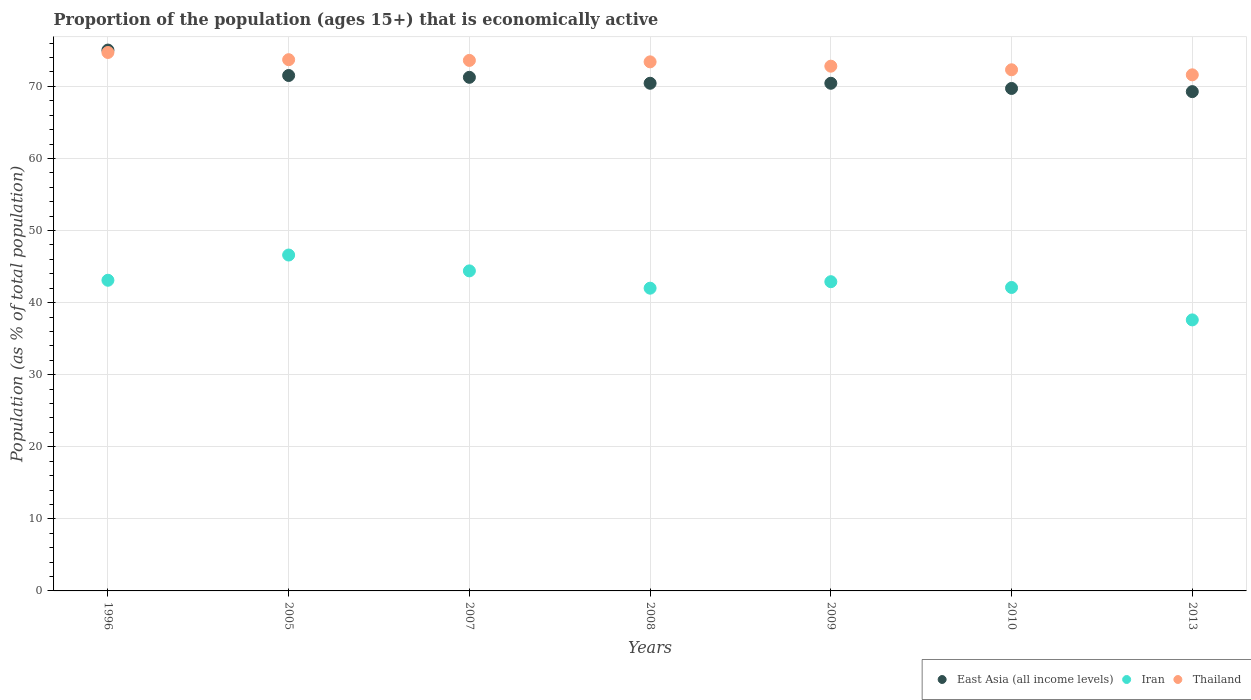How many different coloured dotlines are there?
Provide a succinct answer. 3. What is the proportion of the population that is economically active in Thailand in 2009?
Your answer should be very brief. 72.8. Across all years, what is the maximum proportion of the population that is economically active in East Asia (all income levels)?
Provide a succinct answer. 75.04. Across all years, what is the minimum proportion of the population that is economically active in Iran?
Keep it short and to the point. 37.6. What is the total proportion of the population that is economically active in Iran in the graph?
Offer a very short reply. 298.7. What is the difference between the proportion of the population that is economically active in Thailand in 2008 and that in 2009?
Give a very brief answer. 0.6. What is the difference between the proportion of the population that is economically active in Iran in 2007 and the proportion of the population that is economically active in Thailand in 2010?
Your answer should be very brief. -27.9. What is the average proportion of the population that is economically active in Thailand per year?
Offer a terse response. 73.16. In the year 1996, what is the difference between the proportion of the population that is economically active in Iran and proportion of the population that is economically active in East Asia (all income levels)?
Keep it short and to the point. -31.94. What is the ratio of the proportion of the population that is economically active in East Asia (all income levels) in 1996 to that in 2005?
Your response must be concise. 1.05. Is the proportion of the population that is economically active in East Asia (all income levels) in 2009 less than that in 2013?
Make the answer very short. No. What is the difference between the highest and the second highest proportion of the population that is economically active in East Asia (all income levels)?
Offer a terse response. 3.53. What is the difference between the highest and the lowest proportion of the population that is economically active in Thailand?
Ensure brevity in your answer.  3.1. In how many years, is the proportion of the population that is economically active in Thailand greater than the average proportion of the population that is economically active in Thailand taken over all years?
Provide a short and direct response. 4. Is the sum of the proportion of the population that is economically active in East Asia (all income levels) in 2007 and 2009 greater than the maximum proportion of the population that is economically active in Iran across all years?
Provide a short and direct response. Yes. Is it the case that in every year, the sum of the proportion of the population that is economically active in Iran and proportion of the population that is economically active in Thailand  is greater than the proportion of the population that is economically active in East Asia (all income levels)?
Your response must be concise. Yes. Is the proportion of the population that is economically active in East Asia (all income levels) strictly less than the proportion of the population that is economically active in Iran over the years?
Make the answer very short. No. What is the difference between two consecutive major ticks on the Y-axis?
Make the answer very short. 10. Does the graph contain grids?
Make the answer very short. Yes. How are the legend labels stacked?
Offer a terse response. Horizontal. What is the title of the graph?
Make the answer very short. Proportion of the population (ages 15+) that is economically active. Does "Sweden" appear as one of the legend labels in the graph?
Your answer should be compact. No. What is the label or title of the Y-axis?
Your answer should be compact. Population (as % of total population). What is the Population (as % of total population) in East Asia (all income levels) in 1996?
Your answer should be compact. 75.04. What is the Population (as % of total population) in Iran in 1996?
Provide a short and direct response. 43.1. What is the Population (as % of total population) in Thailand in 1996?
Provide a short and direct response. 74.7. What is the Population (as % of total population) in East Asia (all income levels) in 2005?
Provide a succinct answer. 71.51. What is the Population (as % of total population) in Iran in 2005?
Give a very brief answer. 46.6. What is the Population (as % of total population) in Thailand in 2005?
Your answer should be compact. 73.7. What is the Population (as % of total population) of East Asia (all income levels) in 2007?
Provide a succinct answer. 71.25. What is the Population (as % of total population) in Iran in 2007?
Offer a terse response. 44.4. What is the Population (as % of total population) of Thailand in 2007?
Ensure brevity in your answer.  73.6. What is the Population (as % of total population) of East Asia (all income levels) in 2008?
Your response must be concise. 70.43. What is the Population (as % of total population) of Thailand in 2008?
Your response must be concise. 73.4. What is the Population (as % of total population) of East Asia (all income levels) in 2009?
Keep it short and to the point. 70.43. What is the Population (as % of total population) of Iran in 2009?
Keep it short and to the point. 42.9. What is the Population (as % of total population) of Thailand in 2009?
Your response must be concise. 72.8. What is the Population (as % of total population) in East Asia (all income levels) in 2010?
Your answer should be compact. 69.71. What is the Population (as % of total population) of Iran in 2010?
Give a very brief answer. 42.1. What is the Population (as % of total population) in Thailand in 2010?
Make the answer very short. 72.3. What is the Population (as % of total population) in East Asia (all income levels) in 2013?
Your answer should be compact. 69.27. What is the Population (as % of total population) in Iran in 2013?
Ensure brevity in your answer.  37.6. What is the Population (as % of total population) of Thailand in 2013?
Ensure brevity in your answer.  71.6. Across all years, what is the maximum Population (as % of total population) in East Asia (all income levels)?
Offer a terse response. 75.04. Across all years, what is the maximum Population (as % of total population) of Iran?
Make the answer very short. 46.6. Across all years, what is the maximum Population (as % of total population) of Thailand?
Keep it short and to the point. 74.7. Across all years, what is the minimum Population (as % of total population) of East Asia (all income levels)?
Keep it short and to the point. 69.27. Across all years, what is the minimum Population (as % of total population) in Iran?
Provide a succinct answer. 37.6. Across all years, what is the minimum Population (as % of total population) in Thailand?
Provide a short and direct response. 71.6. What is the total Population (as % of total population) of East Asia (all income levels) in the graph?
Your answer should be compact. 497.63. What is the total Population (as % of total population) in Iran in the graph?
Offer a very short reply. 298.7. What is the total Population (as % of total population) in Thailand in the graph?
Offer a very short reply. 512.1. What is the difference between the Population (as % of total population) in East Asia (all income levels) in 1996 and that in 2005?
Offer a very short reply. 3.53. What is the difference between the Population (as % of total population) in Thailand in 1996 and that in 2005?
Offer a very short reply. 1. What is the difference between the Population (as % of total population) of East Asia (all income levels) in 1996 and that in 2007?
Your answer should be very brief. 3.78. What is the difference between the Population (as % of total population) in Iran in 1996 and that in 2007?
Your answer should be compact. -1.3. What is the difference between the Population (as % of total population) of Thailand in 1996 and that in 2007?
Ensure brevity in your answer.  1.1. What is the difference between the Population (as % of total population) in East Asia (all income levels) in 1996 and that in 2008?
Ensure brevity in your answer.  4.61. What is the difference between the Population (as % of total population) in East Asia (all income levels) in 1996 and that in 2009?
Ensure brevity in your answer.  4.61. What is the difference between the Population (as % of total population) in Iran in 1996 and that in 2009?
Your response must be concise. 0.2. What is the difference between the Population (as % of total population) of East Asia (all income levels) in 1996 and that in 2010?
Make the answer very short. 5.33. What is the difference between the Population (as % of total population) in Iran in 1996 and that in 2010?
Ensure brevity in your answer.  1. What is the difference between the Population (as % of total population) in East Asia (all income levels) in 1996 and that in 2013?
Your answer should be very brief. 5.77. What is the difference between the Population (as % of total population) in Iran in 1996 and that in 2013?
Offer a very short reply. 5.5. What is the difference between the Population (as % of total population) in East Asia (all income levels) in 2005 and that in 2007?
Your answer should be very brief. 0.25. What is the difference between the Population (as % of total population) of East Asia (all income levels) in 2005 and that in 2008?
Give a very brief answer. 1.08. What is the difference between the Population (as % of total population) of Iran in 2005 and that in 2008?
Your answer should be very brief. 4.6. What is the difference between the Population (as % of total population) of East Asia (all income levels) in 2005 and that in 2009?
Offer a very short reply. 1.08. What is the difference between the Population (as % of total population) in East Asia (all income levels) in 2005 and that in 2010?
Provide a succinct answer. 1.8. What is the difference between the Population (as % of total population) of Iran in 2005 and that in 2010?
Offer a very short reply. 4.5. What is the difference between the Population (as % of total population) in East Asia (all income levels) in 2005 and that in 2013?
Your response must be concise. 2.24. What is the difference between the Population (as % of total population) in Iran in 2005 and that in 2013?
Your response must be concise. 9. What is the difference between the Population (as % of total population) in Thailand in 2005 and that in 2013?
Keep it short and to the point. 2.1. What is the difference between the Population (as % of total population) of East Asia (all income levels) in 2007 and that in 2008?
Provide a succinct answer. 0.82. What is the difference between the Population (as % of total population) of Thailand in 2007 and that in 2008?
Keep it short and to the point. 0.2. What is the difference between the Population (as % of total population) of East Asia (all income levels) in 2007 and that in 2009?
Your response must be concise. 0.83. What is the difference between the Population (as % of total population) of East Asia (all income levels) in 2007 and that in 2010?
Make the answer very short. 1.55. What is the difference between the Population (as % of total population) of Iran in 2007 and that in 2010?
Give a very brief answer. 2.3. What is the difference between the Population (as % of total population) of Thailand in 2007 and that in 2010?
Ensure brevity in your answer.  1.3. What is the difference between the Population (as % of total population) of East Asia (all income levels) in 2007 and that in 2013?
Offer a very short reply. 1.99. What is the difference between the Population (as % of total population) in East Asia (all income levels) in 2008 and that in 2009?
Offer a very short reply. 0. What is the difference between the Population (as % of total population) of Iran in 2008 and that in 2009?
Provide a short and direct response. -0.9. What is the difference between the Population (as % of total population) of Thailand in 2008 and that in 2009?
Offer a very short reply. 0.6. What is the difference between the Population (as % of total population) in East Asia (all income levels) in 2008 and that in 2010?
Your answer should be compact. 0.72. What is the difference between the Population (as % of total population) in Iran in 2008 and that in 2010?
Offer a very short reply. -0.1. What is the difference between the Population (as % of total population) of East Asia (all income levels) in 2008 and that in 2013?
Ensure brevity in your answer.  1.16. What is the difference between the Population (as % of total population) of East Asia (all income levels) in 2009 and that in 2010?
Provide a short and direct response. 0.72. What is the difference between the Population (as % of total population) in Iran in 2009 and that in 2010?
Provide a short and direct response. 0.8. What is the difference between the Population (as % of total population) of East Asia (all income levels) in 2009 and that in 2013?
Provide a short and direct response. 1.16. What is the difference between the Population (as % of total population) in Iran in 2009 and that in 2013?
Offer a very short reply. 5.3. What is the difference between the Population (as % of total population) of Thailand in 2009 and that in 2013?
Make the answer very short. 1.2. What is the difference between the Population (as % of total population) of East Asia (all income levels) in 2010 and that in 2013?
Keep it short and to the point. 0.44. What is the difference between the Population (as % of total population) of Thailand in 2010 and that in 2013?
Keep it short and to the point. 0.7. What is the difference between the Population (as % of total population) in East Asia (all income levels) in 1996 and the Population (as % of total population) in Iran in 2005?
Make the answer very short. 28.44. What is the difference between the Population (as % of total population) of East Asia (all income levels) in 1996 and the Population (as % of total population) of Thailand in 2005?
Your answer should be very brief. 1.34. What is the difference between the Population (as % of total population) in Iran in 1996 and the Population (as % of total population) in Thailand in 2005?
Give a very brief answer. -30.6. What is the difference between the Population (as % of total population) of East Asia (all income levels) in 1996 and the Population (as % of total population) of Iran in 2007?
Make the answer very short. 30.64. What is the difference between the Population (as % of total population) of East Asia (all income levels) in 1996 and the Population (as % of total population) of Thailand in 2007?
Keep it short and to the point. 1.44. What is the difference between the Population (as % of total population) of Iran in 1996 and the Population (as % of total population) of Thailand in 2007?
Your answer should be compact. -30.5. What is the difference between the Population (as % of total population) of East Asia (all income levels) in 1996 and the Population (as % of total population) of Iran in 2008?
Offer a terse response. 33.04. What is the difference between the Population (as % of total population) of East Asia (all income levels) in 1996 and the Population (as % of total population) of Thailand in 2008?
Your response must be concise. 1.64. What is the difference between the Population (as % of total population) of Iran in 1996 and the Population (as % of total population) of Thailand in 2008?
Provide a succinct answer. -30.3. What is the difference between the Population (as % of total population) in East Asia (all income levels) in 1996 and the Population (as % of total population) in Iran in 2009?
Offer a terse response. 32.14. What is the difference between the Population (as % of total population) in East Asia (all income levels) in 1996 and the Population (as % of total population) in Thailand in 2009?
Your answer should be compact. 2.24. What is the difference between the Population (as % of total population) of Iran in 1996 and the Population (as % of total population) of Thailand in 2009?
Offer a terse response. -29.7. What is the difference between the Population (as % of total population) in East Asia (all income levels) in 1996 and the Population (as % of total population) in Iran in 2010?
Offer a very short reply. 32.94. What is the difference between the Population (as % of total population) of East Asia (all income levels) in 1996 and the Population (as % of total population) of Thailand in 2010?
Your response must be concise. 2.74. What is the difference between the Population (as % of total population) of Iran in 1996 and the Population (as % of total population) of Thailand in 2010?
Provide a short and direct response. -29.2. What is the difference between the Population (as % of total population) of East Asia (all income levels) in 1996 and the Population (as % of total population) of Iran in 2013?
Your answer should be very brief. 37.44. What is the difference between the Population (as % of total population) in East Asia (all income levels) in 1996 and the Population (as % of total population) in Thailand in 2013?
Offer a very short reply. 3.44. What is the difference between the Population (as % of total population) in Iran in 1996 and the Population (as % of total population) in Thailand in 2013?
Provide a short and direct response. -28.5. What is the difference between the Population (as % of total population) of East Asia (all income levels) in 2005 and the Population (as % of total population) of Iran in 2007?
Keep it short and to the point. 27.11. What is the difference between the Population (as % of total population) in East Asia (all income levels) in 2005 and the Population (as % of total population) in Thailand in 2007?
Your answer should be compact. -2.09. What is the difference between the Population (as % of total population) in East Asia (all income levels) in 2005 and the Population (as % of total population) in Iran in 2008?
Provide a succinct answer. 29.51. What is the difference between the Population (as % of total population) in East Asia (all income levels) in 2005 and the Population (as % of total population) in Thailand in 2008?
Your response must be concise. -1.89. What is the difference between the Population (as % of total population) in Iran in 2005 and the Population (as % of total population) in Thailand in 2008?
Offer a terse response. -26.8. What is the difference between the Population (as % of total population) in East Asia (all income levels) in 2005 and the Population (as % of total population) in Iran in 2009?
Keep it short and to the point. 28.61. What is the difference between the Population (as % of total population) of East Asia (all income levels) in 2005 and the Population (as % of total population) of Thailand in 2009?
Make the answer very short. -1.29. What is the difference between the Population (as % of total population) of Iran in 2005 and the Population (as % of total population) of Thailand in 2009?
Offer a very short reply. -26.2. What is the difference between the Population (as % of total population) in East Asia (all income levels) in 2005 and the Population (as % of total population) in Iran in 2010?
Make the answer very short. 29.41. What is the difference between the Population (as % of total population) of East Asia (all income levels) in 2005 and the Population (as % of total population) of Thailand in 2010?
Make the answer very short. -0.79. What is the difference between the Population (as % of total population) of Iran in 2005 and the Population (as % of total population) of Thailand in 2010?
Your answer should be compact. -25.7. What is the difference between the Population (as % of total population) in East Asia (all income levels) in 2005 and the Population (as % of total population) in Iran in 2013?
Provide a short and direct response. 33.91. What is the difference between the Population (as % of total population) in East Asia (all income levels) in 2005 and the Population (as % of total population) in Thailand in 2013?
Offer a terse response. -0.09. What is the difference between the Population (as % of total population) of Iran in 2005 and the Population (as % of total population) of Thailand in 2013?
Provide a short and direct response. -25. What is the difference between the Population (as % of total population) in East Asia (all income levels) in 2007 and the Population (as % of total population) in Iran in 2008?
Provide a succinct answer. 29.25. What is the difference between the Population (as % of total population) in East Asia (all income levels) in 2007 and the Population (as % of total population) in Thailand in 2008?
Your answer should be compact. -2.15. What is the difference between the Population (as % of total population) of Iran in 2007 and the Population (as % of total population) of Thailand in 2008?
Offer a very short reply. -29. What is the difference between the Population (as % of total population) of East Asia (all income levels) in 2007 and the Population (as % of total population) of Iran in 2009?
Offer a very short reply. 28.35. What is the difference between the Population (as % of total population) in East Asia (all income levels) in 2007 and the Population (as % of total population) in Thailand in 2009?
Your answer should be very brief. -1.55. What is the difference between the Population (as % of total population) in Iran in 2007 and the Population (as % of total population) in Thailand in 2009?
Provide a succinct answer. -28.4. What is the difference between the Population (as % of total population) of East Asia (all income levels) in 2007 and the Population (as % of total population) of Iran in 2010?
Make the answer very short. 29.15. What is the difference between the Population (as % of total population) of East Asia (all income levels) in 2007 and the Population (as % of total population) of Thailand in 2010?
Provide a short and direct response. -1.05. What is the difference between the Population (as % of total population) in Iran in 2007 and the Population (as % of total population) in Thailand in 2010?
Your answer should be very brief. -27.9. What is the difference between the Population (as % of total population) in East Asia (all income levels) in 2007 and the Population (as % of total population) in Iran in 2013?
Keep it short and to the point. 33.65. What is the difference between the Population (as % of total population) of East Asia (all income levels) in 2007 and the Population (as % of total population) of Thailand in 2013?
Offer a very short reply. -0.35. What is the difference between the Population (as % of total population) in Iran in 2007 and the Population (as % of total population) in Thailand in 2013?
Provide a short and direct response. -27.2. What is the difference between the Population (as % of total population) of East Asia (all income levels) in 2008 and the Population (as % of total population) of Iran in 2009?
Offer a terse response. 27.53. What is the difference between the Population (as % of total population) of East Asia (all income levels) in 2008 and the Population (as % of total population) of Thailand in 2009?
Provide a short and direct response. -2.37. What is the difference between the Population (as % of total population) in Iran in 2008 and the Population (as % of total population) in Thailand in 2009?
Give a very brief answer. -30.8. What is the difference between the Population (as % of total population) in East Asia (all income levels) in 2008 and the Population (as % of total population) in Iran in 2010?
Offer a very short reply. 28.33. What is the difference between the Population (as % of total population) in East Asia (all income levels) in 2008 and the Population (as % of total population) in Thailand in 2010?
Offer a very short reply. -1.87. What is the difference between the Population (as % of total population) in Iran in 2008 and the Population (as % of total population) in Thailand in 2010?
Give a very brief answer. -30.3. What is the difference between the Population (as % of total population) in East Asia (all income levels) in 2008 and the Population (as % of total population) in Iran in 2013?
Your answer should be compact. 32.83. What is the difference between the Population (as % of total population) of East Asia (all income levels) in 2008 and the Population (as % of total population) of Thailand in 2013?
Give a very brief answer. -1.17. What is the difference between the Population (as % of total population) in Iran in 2008 and the Population (as % of total population) in Thailand in 2013?
Your answer should be compact. -29.6. What is the difference between the Population (as % of total population) in East Asia (all income levels) in 2009 and the Population (as % of total population) in Iran in 2010?
Provide a short and direct response. 28.33. What is the difference between the Population (as % of total population) in East Asia (all income levels) in 2009 and the Population (as % of total population) in Thailand in 2010?
Provide a succinct answer. -1.87. What is the difference between the Population (as % of total population) of Iran in 2009 and the Population (as % of total population) of Thailand in 2010?
Keep it short and to the point. -29.4. What is the difference between the Population (as % of total population) in East Asia (all income levels) in 2009 and the Population (as % of total population) in Iran in 2013?
Offer a terse response. 32.83. What is the difference between the Population (as % of total population) in East Asia (all income levels) in 2009 and the Population (as % of total population) in Thailand in 2013?
Keep it short and to the point. -1.17. What is the difference between the Population (as % of total population) of Iran in 2009 and the Population (as % of total population) of Thailand in 2013?
Make the answer very short. -28.7. What is the difference between the Population (as % of total population) of East Asia (all income levels) in 2010 and the Population (as % of total population) of Iran in 2013?
Ensure brevity in your answer.  32.11. What is the difference between the Population (as % of total population) of East Asia (all income levels) in 2010 and the Population (as % of total population) of Thailand in 2013?
Your answer should be compact. -1.89. What is the difference between the Population (as % of total population) in Iran in 2010 and the Population (as % of total population) in Thailand in 2013?
Your response must be concise. -29.5. What is the average Population (as % of total population) of East Asia (all income levels) per year?
Your response must be concise. 71.09. What is the average Population (as % of total population) of Iran per year?
Ensure brevity in your answer.  42.67. What is the average Population (as % of total population) in Thailand per year?
Provide a succinct answer. 73.16. In the year 1996, what is the difference between the Population (as % of total population) in East Asia (all income levels) and Population (as % of total population) in Iran?
Your answer should be very brief. 31.94. In the year 1996, what is the difference between the Population (as % of total population) of East Asia (all income levels) and Population (as % of total population) of Thailand?
Your answer should be compact. 0.34. In the year 1996, what is the difference between the Population (as % of total population) in Iran and Population (as % of total population) in Thailand?
Your answer should be very brief. -31.6. In the year 2005, what is the difference between the Population (as % of total population) in East Asia (all income levels) and Population (as % of total population) in Iran?
Ensure brevity in your answer.  24.91. In the year 2005, what is the difference between the Population (as % of total population) of East Asia (all income levels) and Population (as % of total population) of Thailand?
Offer a very short reply. -2.19. In the year 2005, what is the difference between the Population (as % of total population) in Iran and Population (as % of total population) in Thailand?
Make the answer very short. -27.1. In the year 2007, what is the difference between the Population (as % of total population) of East Asia (all income levels) and Population (as % of total population) of Iran?
Keep it short and to the point. 26.85. In the year 2007, what is the difference between the Population (as % of total population) in East Asia (all income levels) and Population (as % of total population) in Thailand?
Your answer should be very brief. -2.35. In the year 2007, what is the difference between the Population (as % of total population) of Iran and Population (as % of total population) of Thailand?
Offer a very short reply. -29.2. In the year 2008, what is the difference between the Population (as % of total population) in East Asia (all income levels) and Population (as % of total population) in Iran?
Ensure brevity in your answer.  28.43. In the year 2008, what is the difference between the Population (as % of total population) in East Asia (all income levels) and Population (as % of total population) in Thailand?
Ensure brevity in your answer.  -2.97. In the year 2008, what is the difference between the Population (as % of total population) of Iran and Population (as % of total population) of Thailand?
Ensure brevity in your answer.  -31.4. In the year 2009, what is the difference between the Population (as % of total population) in East Asia (all income levels) and Population (as % of total population) in Iran?
Your answer should be compact. 27.53. In the year 2009, what is the difference between the Population (as % of total population) of East Asia (all income levels) and Population (as % of total population) of Thailand?
Provide a succinct answer. -2.37. In the year 2009, what is the difference between the Population (as % of total population) of Iran and Population (as % of total population) of Thailand?
Ensure brevity in your answer.  -29.9. In the year 2010, what is the difference between the Population (as % of total population) in East Asia (all income levels) and Population (as % of total population) in Iran?
Your response must be concise. 27.61. In the year 2010, what is the difference between the Population (as % of total population) of East Asia (all income levels) and Population (as % of total population) of Thailand?
Give a very brief answer. -2.59. In the year 2010, what is the difference between the Population (as % of total population) of Iran and Population (as % of total population) of Thailand?
Make the answer very short. -30.2. In the year 2013, what is the difference between the Population (as % of total population) in East Asia (all income levels) and Population (as % of total population) in Iran?
Keep it short and to the point. 31.67. In the year 2013, what is the difference between the Population (as % of total population) of East Asia (all income levels) and Population (as % of total population) of Thailand?
Offer a terse response. -2.33. In the year 2013, what is the difference between the Population (as % of total population) of Iran and Population (as % of total population) of Thailand?
Make the answer very short. -34. What is the ratio of the Population (as % of total population) in East Asia (all income levels) in 1996 to that in 2005?
Provide a succinct answer. 1.05. What is the ratio of the Population (as % of total population) of Iran in 1996 to that in 2005?
Provide a short and direct response. 0.92. What is the ratio of the Population (as % of total population) of Thailand in 1996 to that in 2005?
Ensure brevity in your answer.  1.01. What is the ratio of the Population (as % of total population) in East Asia (all income levels) in 1996 to that in 2007?
Ensure brevity in your answer.  1.05. What is the ratio of the Population (as % of total population) in Iran in 1996 to that in 2007?
Give a very brief answer. 0.97. What is the ratio of the Population (as % of total population) of Thailand in 1996 to that in 2007?
Ensure brevity in your answer.  1.01. What is the ratio of the Population (as % of total population) of East Asia (all income levels) in 1996 to that in 2008?
Offer a very short reply. 1.07. What is the ratio of the Population (as % of total population) in Iran in 1996 to that in 2008?
Ensure brevity in your answer.  1.03. What is the ratio of the Population (as % of total population) of Thailand in 1996 to that in 2008?
Ensure brevity in your answer.  1.02. What is the ratio of the Population (as % of total population) of East Asia (all income levels) in 1996 to that in 2009?
Make the answer very short. 1.07. What is the ratio of the Population (as % of total population) of Iran in 1996 to that in 2009?
Give a very brief answer. 1. What is the ratio of the Population (as % of total population) in Thailand in 1996 to that in 2009?
Your answer should be compact. 1.03. What is the ratio of the Population (as % of total population) of East Asia (all income levels) in 1996 to that in 2010?
Your answer should be very brief. 1.08. What is the ratio of the Population (as % of total population) in Iran in 1996 to that in 2010?
Make the answer very short. 1.02. What is the ratio of the Population (as % of total population) of Thailand in 1996 to that in 2010?
Your answer should be compact. 1.03. What is the ratio of the Population (as % of total population) in East Asia (all income levels) in 1996 to that in 2013?
Your response must be concise. 1.08. What is the ratio of the Population (as % of total population) of Iran in 1996 to that in 2013?
Offer a terse response. 1.15. What is the ratio of the Population (as % of total population) in Thailand in 1996 to that in 2013?
Provide a short and direct response. 1.04. What is the ratio of the Population (as % of total population) of Iran in 2005 to that in 2007?
Provide a succinct answer. 1.05. What is the ratio of the Population (as % of total population) in East Asia (all income levels) in 2005 to that in 2008?
Provide a succinct answer. 1.02. What is the ratio of the Population (as % of total population) in Iran in 2005 to that in 2008?
Your answer should be very brief. 1.11. What is the ratio of the Population (as % of total population) in Thailand in 2005 to that in 2008?
Provide a succinct answer. 1. What is the ratio of the Population (as % of total population) of East Asia (all income levels) in 2005 to that in 2009?
Keep it short and to the point. 1.02. What is the ratio of the Population (as % of total population) in Iran in 2005 to that in 2009?
Provide a short and direct response. 1.09. What is the ratio of the Population (as % of total population) of Thailand in 2005 to that in 2009?
Ensure brevity in your answer.  1.01. What is the ratio of the Population (as % of total population) in East Asia (all income levels) in 2005 to that in 2010?
Ensure brevity in your answer.  1.03. What is the ratio of the Population (as % of total population) in Iran in 2005 to that in 2010?
Offer a terse response. 1.11. What is the ratio of the Population (as % of total population) of Thailand in 2005 to that in 2010?
Your answer should be compact. 1.02. What is the ratio of the Population (as % of total population) of East Asia (all income levels) in 2005 to that in 2013?
Offer a terse response. 1.03. What is the ratio of the Population (as % of total population) of Iran in 2005 to that in 2013?
Provide a short and direct response. 1.24. What is the ratio of the Population (as % of total population) in Thailand in 2005 to that in 2013?
Offer a very short reply. 1.03. What is the ratio of the Population (as % of total population) in East Asia (all income levels) in 2007 to that in 2008?
Keep it short and to the point. 1.01. What is the ratio of the Population (as % of total population) of Iran in 2007 to that in 2008?
Offer a very short reply. 1.06. What is the ratio of the Population (as % of total population) in Thailand in 2007 to that in 2008?
Provide a succinct answer. 1. What is the ratio of the Population (as % of total population) of East Asia (all income levels) in 2007 to that in 2009?
Your response must be concise. 1.01. What is the ratio of the Population (as % of total population) of Iran in 2007 to that in 2009?
Offer a terse response. 1.03. What is the ratio of the Population (as % of total population) in Thailand in 2007 to that in 2009?
Give a very brief answer. 1.01. What is the ratio of the Population (as % of total population) of East Asia (all income levels) in 2007 to that in 2010?
Your answer should be very brief. 1.02. What is the ratio of the Population (as % of total population) in Iran in 2007 to that in 2010?
Offer a very short reply. 1.05. What is the ratio of the Population (as % of total population) of Thailand in 2007 to that in 2010?
Your response must be concise. 1.02. What is the ratio of the Population (as % of total population) in East Asia (all income levels) in 2007 to that in 2013?
Your answer should be compact. 1.03. What is the ratio of the Population (as % of total population) of Iran in 2007 to that in 2013?
Offer a terse response. 1.18. What is the ratio of the Population (as % of total population) in Thailand in 2007 to that in 2013?
Your answer should be very brief. 1.03. What is the ratio of the Population (as % of total population) in Thailand in 2008 to that in 2009?
Provide a short and direct response. 1.01. What is the ratio of the Population (as % of total population) of East Asia (all income levels) in 2008 to that in 2010?
Offer a terse response. 1.01. What is the ratio of the Population (as % of total population) of Iran in 2008 to that in 2010?
Ensure brevity in your answer.  1. What is the ratio of the Population (as % of total population) of Thailand in 2008 to that in 2010?
Keep it short and to the point. 1.02. What is the ratio of the Population (as % of total population) in East Asia (all income levels) in 2008 to that in 2013?
Provide a short and direct response. 1.02. What is the ratio of the Population (as % of total population) of Iran in 2008 to that in 2013?
Offer a terse response. 1.12. What is the ratio of the Population (as % of total population) in Thailand in 2008 to that in 2013?
Your response must be concise. 1.03. What is the ratio of the Population (as % of total population) in East Asia (all income levels) in 2009 to that in 2010?
Offer a very short reply. 1.01. What is the ratio of the Population (as % of total population) in Iran in 2009 to that in 2010?
Your answer should be compact. 1.02. What is the ratio of the Population (as % of total population) of East Asia (all income levels) in 2009 to that in 2013?
Your response must be concise. 1.02. What is the ratio of the Population (as % of total population) of Iran in 2009 to that in 2013?
Your answer should be very brief. 1.14. What is the ratio of the Population (as % of total population) of Thailand in 2009 to that in 2013?
Offer a very short reply. 1.02. What is the ratio of the Population (as % of total population) of East Asia (all income levels) in 2010 to that in 2013?
Offer a terse response. 1.01. What is the ratio of the Population (as % of total population) in Iran in 2010 to that in 2013?
Ensure brevity in your answer.  1.12. What is the ratio of the Population (as % of total population) of Thailand in 2010 to that in 2013?
Make the answer very short. 1.01. What is the difference between the highest and the second highest Population (as % of total population) in East Asia (all income levels)?
Ensure brevity in your answer.  3.53. What is the difference between the highest and the lowest Population (as % of total population) in East Asia (all income levels)?
Provide a succinct answer. 5.77. What is the difference between the highest and the lowest Population (as % of total population) of Thailand?
Make the answer very short. 3.1. 